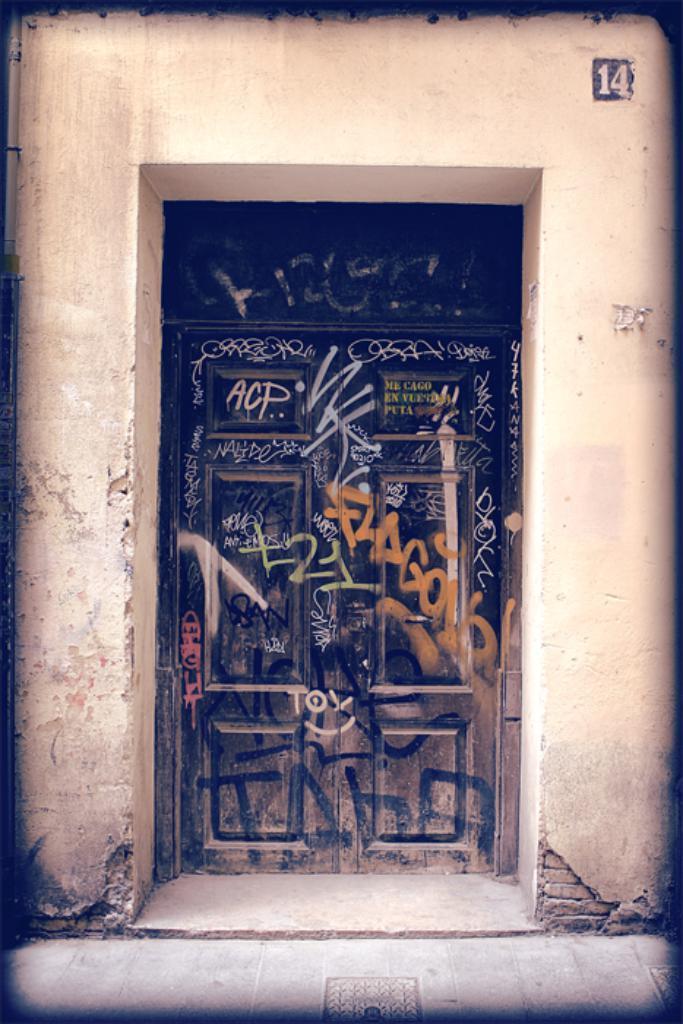Can you describe this image briefly? In this image there is a wall having a door. On the door there is some text painted. Bottom of the image there is a floor. 